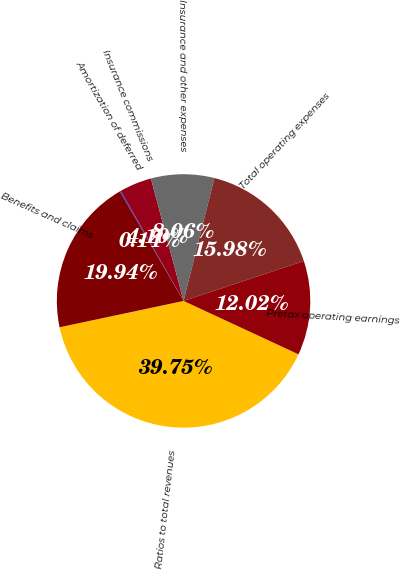Convert chart to OTSL. <chart><loc_0><loc_0><loc_500><loc_500><pie_chart><fcel>Ratios to total revenues<fcel>Benefits and claims<fcel>Amortization of deferred<fcel>Insurance commissions<fcel>Insurance and other expenses<fcel>Total operating expenses<fcel>Pretax operating earnings<nl><fcel>39.74%<fcel>19.94%<fcel>0.14%<fcel>4.1%<fcel>8.06%<fcel>15.98%<fcel>12.02%<nl></chart> 